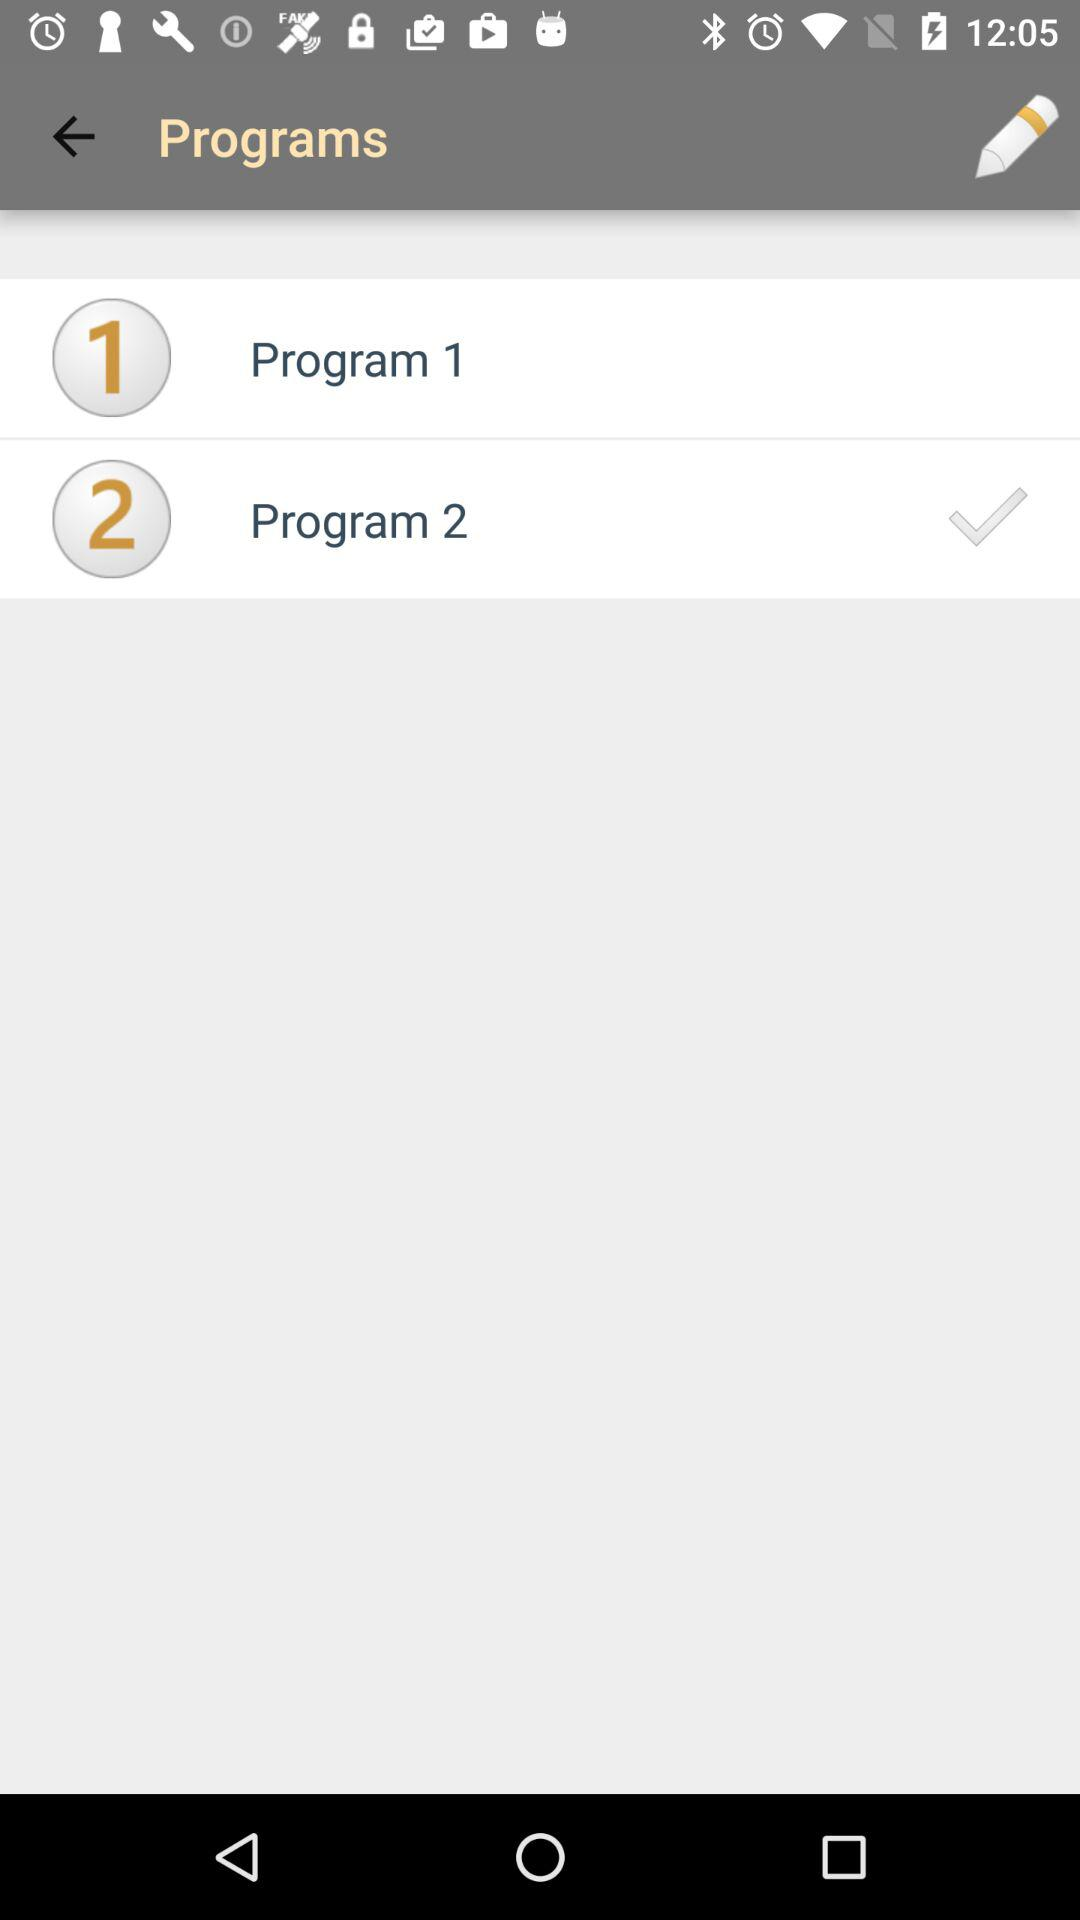Which program is selected? The selected program is "Program 2". 